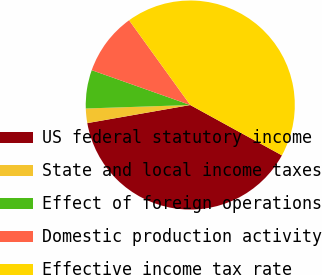Convert chart to OTSL. <chart><loc_0><loc_0><loc_500><loc_500><pie_chart><fcel>US federal statutory income<fcel>State and local income taxes<fcel>Effect of foreign operations<fcel>Domestic production activity<fcel>Effective income tax rate<nl><fcel>39.24%<fcel>2.24%<fcel>5.94%<fcel>9.64%<fcel>42.94%<nl></chart> 